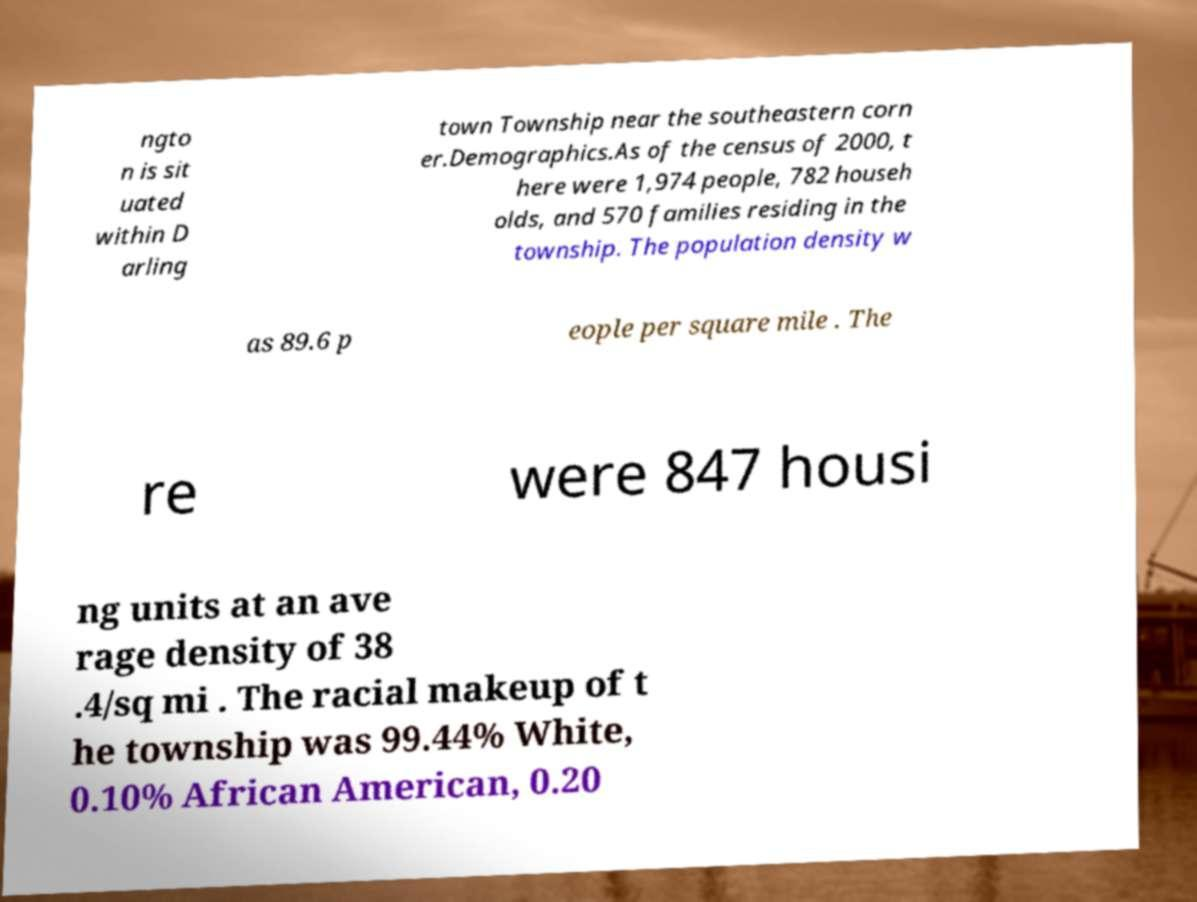What messages or text are displayed in this image? I need them in a readable, typed format. ngto n is sit uated within D arling town Township near the southeastern corn er.Demographics.As of the census of 2000, t here were 1,974 people, 782 househ olds, and 570 families residing in the township. The population density w as 89.6 p eople per square mile . The re were 847 housi ng units at an ave rage density of 38 .4/sq mi . The racial makeup of t he township was 99.44% White, 0.10% African American, 0.20 